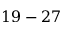<formula> <loc_0><loc_0><loc_500><loc_500>1 9 - 2 7</formula> 